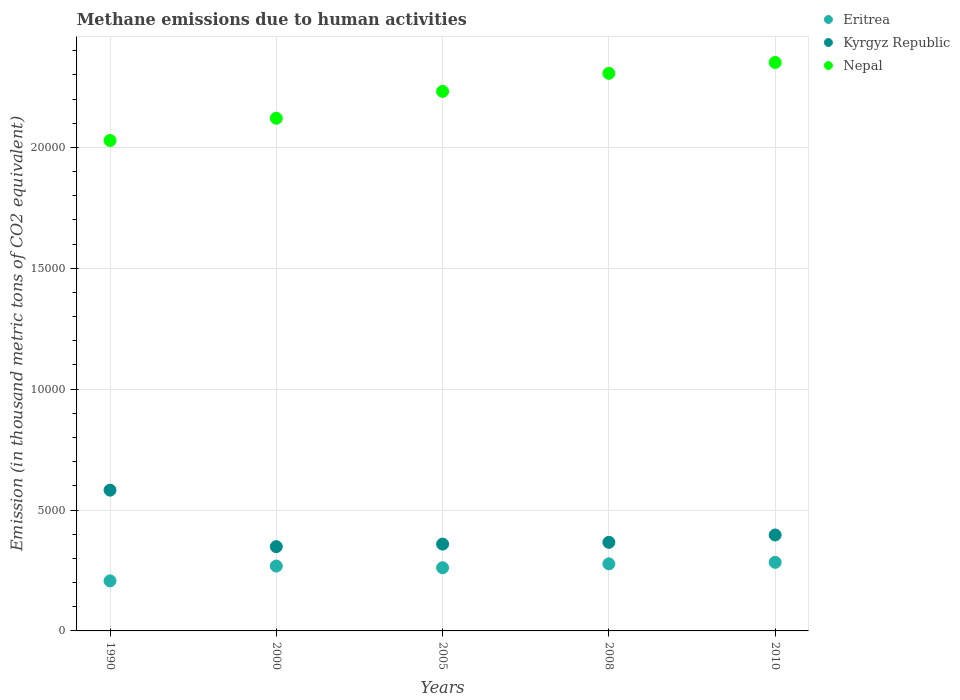How many different coloured dotlines are there?
Provide a short and direct response. 3. What is the amount of methane emitted in Nepal in 2005?
Give a very brief answer. 2.23e+04. Across all years, what is the maximum amount of methane emitted in Nepal?
Ensure brevity in your answer.  2.35e+04. Across all years, what is the minimum amount of methane emitted in Kyrgyz Republic?
Your response must be concise. 3485.8. In which year was the amount of methane emitted in Nepal maximum?
Keep it short and to the point. 2010. What is the total amount of methane emitted in Kyrgyz Republic in the graph?
Ensure brevity in your answer.  2.05e+04. What is the difference between the amount of methane emitted in Nepal in 2000 and that in 2010?
Offer a terse response. -2306. What is the difference between the amount of methane emitted in Nepal in 2010 and the amount of methane emitted in Eritrea in 2008?
Make the answer very short. 2.07e+04. What is the average amount of methane emitted in Eritrea per year?
Provide a succinct answer. 2595.64. In the year 2005, what is the difference between the amount of methane emitted in Eritrea and amount of methane emitted in Kyrgyz Republic?
Give a very brief answer. -977.7. What is the ratio of the amount of methane emitted in Nepal in 2000 to that in 2008?
Your answer should be compact. 0.92. What is the difference between the highest and the second highest amount of methane emitted in Kyrgyz Republic?
Provide a short and direct response. 1854.2. What is the difference between the highest and the lowest amount of methane emitted in Kyrgyz Republic?
Your answer should be compact. 2336.8. In how many years, is the amount of methane emitted in Kyrgyz Republic greater than the average amount of methane emitted in Kyrgyz Republic taken over all years?
Offer a very short reply. 1. Is the sum of the amount of methane emitted in Kyrgyz Republic in 2005 and 2010 greater than the maximum amount of methane emitted in Nepal across all years?
Your response must be concise. No. Is it the case that in every year, the sum of the amount of methane emitted in Nepal and amount of methane emitted in Eritrea  is greater than the amount of methane emitted in Kyrgyz Republic?
Make the answer very short. Yes. Is the amount of methane emitted in Eritrea strictly less than the amount of methane emitted in Nepal over the years?
Give a very brief answer. Yes. How many dotlines are there?
Offer a very short reply. 3. How many years are there in the graph?
Keep it short and to the point. 5. What is the difference between two consecutive major ticks on the Y-axis?
Make the answer very short. 5000. Does the graph contain any zero values?
Keep it short and to the point. No. Where does the legend appear in the graph?
Make the answer very short. Top right. How many legend labels are there?
Your answer should be very brief. 3. How are the legend labels stacked?
Offer a very short reply. Vertical. What is the title of the graph?
Provide a short and direct response. Methane emissions due to human activities. What is the label or title of the X-axis?
Your response must be concise. Years. What is the label or title of the Y-axis?
Offer a terse response. Emission (in thousand metric tons of CO2 equivalent). What is the Emission (in thousand metric tons of CO2 equivalent) in Eritrea in 1990?
Your answer should be very brief. 2070.6. What is the Emission (in thousand metric tons of CO2 equivalent) in Kyrgyz Republic in 1990?
Ensure brevity in your answer.  5822.6. What is the Emission (in thousand metric tons of CO2 equivalent) in Nepal in 1990?
Give a very brief answer. 2.03e+04. What is the Emission (in thousand metric tons of CO2 equivalent) in Eritrea in 2000?
Your answer should be compact. 2682.3. What is the Emission (in thousand metric tons of CO2 equivalent) of Kyrgyz Republic in 2000?
Provide a short and direct response. 3485.8. What is the Emission (in thousand metric tons of CO2 equivalent) of Nepal in 2000?
Give a very brief answer. 2.12e+04. What is the Emission (in thousand metric tons of CO2 equivalent) of Eritrea in 2005?
Make the answer very short. 2613.6. What is the Emission (in thousand metric tons of CO2 equivalent) in Kyrgyz Republic in 2005?
Offer a terse response. 3591.3. What is the Emission (in thousand metric tons of CO2 equivalent) of Nepal in 2005?
Ensure brevity in your answer.  2.23e+04. What is the Emission (in thousand metric tons of CO2 equivalent) in Eritrea in 2008?
Your response must be concise. 2774.7. What is the Emission (in thousand metric tons of CO2 equivalent) of Kyrgyz Republic in 2008?
Provide a succinct answer. 3664.5. What is the Emission (in thousand metric tons of CO2 equivalent) of Nepal in 2008?
Offer a very short reply. 2.31e+04. What is the Emission (in thousand metric tons of CO2 equivalent) in Eritrea in 2010?
Give a very brief answer. 2837. What is the Emission (in thousand metric tons of CO2 equivalent) of Kyrgyz Republic in 2010?
Your response must be concise. 3968.4. What is the Emission (in thousand metric tons of CO2 equivalent) of Nepal in 2010?
Your answer should be very brief. 2.35e+04. Across all years, what is the maximum Emission (in thousand metric tons of CO2 equivalent) in Eritrea?
Give a very brief answer. 2837. Across all years, what is the maximum Emission (in thousand metric tons of CO2 equivalent) of Kyrgyz Republic?
Offer a very short reply. 5822.6. Across all years, what is the maximum Emission (in thousand metric tons of CO2 equivalent) in Nepal?
Provide a succinct answer. 2.35e+04. Across all years, what is the minimum Emission (in thousand metric tons of CO2 equivalent) of Eritrea?
Keep it short and to the point. 2070.6. Across all years, what is the minimum Emission (in thousand metric tons of CO2 equivalent) in Kyrgyz Republic?
Ensure brevity in your answer.  3485.8. Across all years, what is the minimum Emission (in thousand metric tons of CO2 equivalent) of Nepal?
Make the answer very short. 2.03e+04. What is the total Emission (in thousand metric tons of CO2 equivalent) in Eritrea in the graph?
Your answer should be very brief. 1.30e+04. What is the total Emission (in thousand metric tons of CO2 equivalent) in Kyrgyz Republic in the graph?
Your response must be concise. 2.05e+04. What is the total Emission (in thousand metric tons of CO2 equivalent) of Nepal in the graph?
Offer a very short reply. 1.10e+05. What is the difference between the Emission (in thousand metric tons of CO2 equivalent) of Eritrea in 1990 and that in 2000?
Your response must be concise. -611.7. What is the difference between the Emission (in thousand metric tons of CO2 equivalent) of Kyrgyz Republic in 1990 and that in 2000?
Your response must be concise. 2336.8. What is the difference between the Emission (in thousand metric tons of CO2 equivalent) in Nepal in 1990 and that in 2000?
Provide a short and direct response. -920.3. What is the difference between the Emission (in thousand metric tons of CO2 equivalent) in Eritrea in 1990 and that in 2005?
Give a very brief answer. -543. What is the difference between the Emission (in thousand metric tons of CO2 equivalent) of Kyrgyz Republic in 1990 and that in 2005?
Give a very brief answer. 2231.3. What is the difference between the Emission (in thousand metric tons of CO2 equivalent) in Nepal in 1990 and that in 2005?
Offer a terse response. -2031.1. What is the difference between the Emission (in thousand metric tons of CO2 equivalent) in Eritrea in 1990 and that in 2008?
Give a very brief answer. -704.1. What is the difference between the Emission (in thousand metric tons of CO2 equivalent) in Kyrgyz Republic in 1990 and that in 2008?
Provide a short and direct response. 2158.1. What is the difference between the Emission (in thousand metric tons of CO2 equivalent) of Nepal in 1990 and that in 2008?
Make the answer very short. -2778.1. What is the difference between the Emission (in thousand metric tons of CO2 equivalent) of Eritrea in 1990 and that in 2010?
Provide a succinct answer. -766.4. What is the difference between the Emission (in thousand metric tons of CO2 equivalent) of Kyrgyz Republic in 1990 and that in 2010?
Offer a terse response. 1854.2. What is the difference between the Emission (in thousand metric tons of CO2 equivalent) in Nepal in 1990 and that in 2010?
Provide a short and direct response. -3226.3. What is the difference between the Emission (in thousand metric tons of CO2 equivalent) of Eritrea in 2000 and that in 2005?
Make the answer very short. 68.7. What is the difference between the Emission (in thousand metric tons of CO2 equivalent) in Kyrgyz Republic in 2000 and that in 2005?
Offer a very short reply. -105.5. What is the difference between the Emission (in thousand metric tons of CO2 equivalent) of Nepal in 2000 and that in 2005?
Ensure brevity in your answer.  -1110.8. What is the difference between the Emission (in thousand metric tons of CO2 equivalent) of Eritrea in 2000 and that in 2008?
Your answer should be very brief. -92.4. What is the difference between the Emission (in thousand metric tons of CO2 equivalent) in Kyrgyz Republic in 2000 and that in 2008?
Offer a very short reply. -178.7. What is the difference between the Emission (in thousand metric tons of CO2 equivalent) of Nepal in 2000 and that in 2008?
Your answer should be compact. -1857.8. What is the difference between the Emission (in thousand metric tons of CO2 equivalent) in Eritrea in 2000 and that in 2010?
Offer a terse response. -154.7. What is the difference between the Emission (in thousand metric tons of CO2 equivalent) in Kyrgyz Republic in 2000 and that in 2010?
Your response must be concise. -482.6. What is the difference between the Emission (in thousand metric tons of CO2 equivalent) in Nepal in 2000 and that in 2010?
Your answer should be compact. -2306. What is the difference between the Emission (in thousand metric tons of CO2 equivalent) of Eritrea in 2005 and that in 2008?
Provide a succinct answer. -161.1. What is the difference between the Emission (in thousand metric tons of CO2 equivalent) in Kyrgyz Republic in 2005 and that in 2008?
Give a very brief answer. -73.2. What is the difference between the Emission (in thousand metric tons of CO2 equivalent) of Nepal in 2005 and that in 2008?
Your answer should be compact. -747. What is the difference between the Emission (in thousand metric tons of CO2 equivalent) in Eritrea in 2005 and that in 2010?
Your answer should be very brief. -223.4. What is the difference between the Emission (in thousand metric tons of CO2 equivalent) of Kyrgyz Republic in 2005 and that in 2010?
Offer a very short reply. -377.1. What is the difference between the Emission (in thousand metric tons of CO2 equivalent) of Nepal in 2005 and that in 2010?
Keep it short and to the point. -1195.2. What is the difference between the Emission (in thousand metric tons of CO2 equivalent) in Eritrea in 2008 and that in 2010?
Ensure brevity in your answer.  -62.3. What is the difference between the Emission (in thousand metric tons of CO2 equivalent) of Kyrgyz Republic in 2008 and that in 2010?
Provide a succinct answer. -303.9. What is the difference between the Emission (in thousand metric tons of CO2 equivalent) of Nepal in 2008 and that in 2010?
Give a very brief answer. -448.2. What is the difference between the Emission (in thousand metric tons of CO2 equivalent) of Eritrea in 1990 and the Emission (in thousand metric tons of CO2 equivalent) of Kyrgyz Republic in 2000?
Keep it short and to the point. -1415.2. What is the difference between the Emission (in thousand metric tons of CO2 equivalent) in Eritrea in 1990 and the Emission (in thousand metric tons of CO2 equivalent) in Nepal in 2000?
Ensure brevity in your answer.  -1.91e+04. What is the difference between the Emission (in thousand metric tons of CO2 equivalent) in Kyrgyz Republic in 1990 and the Emission (in thousand metric tons of CO2 equivalent) in Nepal in 2000?
Offer a very short reply. -1.54e+04. What is the difference between the Emission (in thousand metric tons of CO2 equivalent) of Eritrea in 1990 and the Emission (in thousand metric tons of CO2 equivalent) of Kyrgyz Republic in 2005?
Offer a very short reply. -1520.7. What is the difference between the Emission (in thousand metric tons of CO2 equivalent) of Eritrea in 1990 and the Emission (in thousand metric tons of CO2 equivalent) of Nepal in 2005?
Your answer should be very brief. -2.02e+04. What is the difference between the Emission (in thousand metric tons of CO2 equivalent) of Kyrgyz Republic in 1990 and the Emission (in thousand metric tons of CO2 equivalent) of Nepal in 2005?
Make the answer very short. -1.65e+04. What is the difference between the Emission (in thousand metric tons of CO2 equivalent) of Eritrea in 1990 and the Emission (in thousand metric tons of CO2 equivalent) of Kyrgyz Republic in 2008?
Offer a terse response. -1593.9. What is the difference between the Emission (in thousand metric tons of CO2 equivalent) of Eritrea in 1990 and the Emission (in thousand metric tons of CO2 equivalent) of Nepal in 2008?
Keep it short and to the point. -2.10e+04. What is the difference between the Emission (in thousand metric tons of CO2 equivalent) of Kyrgyz Republic in 1990 and the Emission (in thousand metric tons of CO2 equivalent) of Nepal in 2008?
Your answer should be very brief. -1.72e+04. What is the difference between the Emission (in thousand metric tons of CO2 equivalent) in Eritrea in 1990 and the Emission (in thousand metric tons of CO2 equivalent) in Kyrgyz Republic in 2010?
Provide a succinct answer. -1897.8. What is the difference between the Emission (in thousand metric tons of CO2 equivalent) of Eritrea in 1990 and the Emission (in thousand metric tons of CO2 equivalent) of Nepal in 2010?
Your response must be concise. -2.14e+04. What is the difference between the Emission (in thousand metric tons of CO2 equivalent) of Kyrgyz Republic in 1990 and the Emission (in thousand metric tons of CO2 equivalent) of Nepal in 2010?
Ensure brevity in your answer.  -1.77e+04. What is the difference between the Emission (in thousand metric tons of CO2 equivalent) in Eritrea in 2000 and the Emission (in thousand metric tons of CO2 equivalent) in Kyrgyz Republic in 2005?
Your answer should be compact. -909. What is the difference between the Emission (in thousand metric tons of CO2 equivalent) in Eritrea in 2000 and the Emission (in thousand metric tons of CO2 equivalent) in Nepal in 2005?
Your answer should be very brief. -1.96e+04. What is the difference between the Emission (in thousand metric tons of CO2 equivalent) in Kyrgyz Republic in 2000 and the Emission (in thousand metric tons of CO2 equivalent) in Nepal in 2005?
Offer a terse response. -1.88e+04. What is the difference between the Emission (in thousand metric tons of CO2 equivalent) of Eritrea in 2000 and the Emission (in thousand metric tons of CO2 equivalent) of Kyrgyz Republic in 2008?
Provide a succinct answer. -982.2. What is the difference between the Emission (in thousand metric tons of CO2 equivalent) of Eritrea in 2000 and the Emission (in thousand metric tons of CO2 equivalent) of Nepal in 2008?
Your answer should be compact. -2.04e+04. What is the difference between the Emission (in thousand metric tons of CO2 equivalent) in Kyrgyz Republic in 2000 and the Emission (in thousand metric tons of CO2 equivalent) in Nepal in 2008?
Offer a very short reply. -1.96e+04. What is the difference between the Emission (in thousand metric tons of CO2 equivalent) of Eritrea in 2000 and the Emission (in thousand metric tons of CO2 equivalent) of Kyrgyz Republic in 2010?
Ensure brevity in your answer.  -1286.1. What is the difference between the Emission (in thousand metric tons of CO2 equivalent) in Eritrea in 2000 and the Emission (in thousand metric tons of CO2 equivalent) in Nepal in 2010?
Offer a very short reply. -2.08e+04. What is the difference between the Emission (in thousand metric tons of CO2 equivalent) of Kyrgyz Republic in 2000 and the Emission (in thousand metric tons of CO2 equivalent) of Nepal in 2010?
Give a very brief answer. -2.00e+04. What is the difference between the Emission (in thousand metric tons of CO2 equivalent) of Eritrea in 2005 and the Emission (in thousand metric tons of CO2 equivalent) of Kyrgyz Republic in 2008?
Ensure brevity in your answer.  -1050.9. What is the difference between the Emission (in thousand metric tons of CO2 equivalent) of Eritrea in 2005 and the Emission (in thousand metric tons of CO2 equivalent) of Nepal in 2008?
Your response must be concise. -2.05e+04. What is the difference between the Emission (in thousand metric tons of CO2 equivalent) in Kyrgyz Republic in 2005 and the Emission (in thousand metric tons of CO2 equivalent) in Nepal in 2008?
Make the answer very short. -1.95e+04. What is the difference between the Emission (in thousand metric tons of CO2 equivalent) in Eritrea in 2005 and the Emission (in thousand metric tons of CO2 equivalent) in Kyrgyz Republic in 2010?
Keep it short and to the point. -1354.8. What is the difference between the Emission (in thousand metric tons of CO2 equivalent) of Eritrea in 2005 and the Emission (in thousand metric tons of CO2 equivalent) of Nepal in 2010?
Give a very brief answer. -2.09e+04. What is the difference between the Emission (in thousand metric tons of CO2 equivalent) in Kyrgyz Republic in 2005 and the Emission (in thousand metric tons of CO2 equivalent) in Nepal in 2010?
Keep it short and to the point. -1.99e+04. What is the difference between the Emission (in thousand metric tons of CO2 equivalent) in Eritrea in 2008 and the Emission (in thousand metric tons of CO2 equivalent) in Kyrgyz Republic in 2010?
Your answer should be compact. -1193.7. What is the difference between the Emission (in thousand metric tons of CO2 equivalent) in Eritrea in 2008 and the Emission (in thousand metric tons of CO2 equivalent) in Nepal in 2010?
Keep it short and to the point. -2.07e+04. What is the difference between the Emission (in thousand metric tons of CO2 equivalent) in Kyrgyz Republic in 2008 and the Emission (in thousand metric tons of CO2 equivalent) in Nepal in 2010?
Your answer should be very brief. -1.98e+04. What is the average Emission (in thousand metric tons of CO2 equivalent) of Eritrea per year?
Offer a very short reply. 2595.64. What is the average Emission (in thousand metric tons of CO2 equivalent) in Kyrgyz Republic per year?
Offer a very short reply. 4106.52. What is the average Emission (in thousand metric tons of CO2 equivalent) in Nepal per year?
Keep it short and to the point. 2.21e+04. In the year 1990, what is the difference between the Emission (in thousand metric tons of CO2 equivalent) of Eritrea and Emission (in thousand metric tons of CO2 equivalent) of Kyrgyz Republic?
Your answer should be compact. -3752. In the year 1990, what is the difference between the Emission (in thousand metric tons of CO2 equivalent) of Eritrea and Emission (in thousand metric tons of CO2 equivalent) of Nepal?
Provide a succinct answer. -1.82e+04. In the year 1990, what is the difference between the Emission (in thousand metric tons of CO2 equivalent) in Kyrgyz Republic and Emission (in thousand metric tons of CO2 equivalent) in Nepal?
Your answer should be compact. -1.45e+04. In the year 2000, what is the difference between the Emission (in thousand metric tons of CO2 equivalent) in Eritrea and Emission (in thousand metric tons of CO2 equivalent) in Kyrgyz Republic?
Provide a short and direct response. -803.5. In the year 2000, what is the difference between the Emission (in thousand metric tons of CO2 equivalent) of Eritrea and Emission (in thousand metric tons of CO2 equivalent) of Nepal?
Ensure brevity in your answer.  -1.85e+04. In the year 2000, what is the difference between the Emission (in thousand metric tons of CO2 equivalent) of Kyrgyz Republic and Emission (in thousand metric tons of CO2 equivalent) of Nepal?
Your response must be concise. -1.77e+04. In the year 2005, what is the difference between the Emission (in thousand metric tons of CO2 equivalent) in Eritrea and Emission (in thousand metric tons of CO2 equivalent) in Kyrgyz Republic?
Provide a short and direct response. -977.7. In the year 2005, what is the difference between the Emission (in thousand metric tons of CO2 equivalent) of Eritrea and Emission (in thousand metric tons of CO2 equivalent) of Nepal?
Your answer should be very brief. -1.97e+04. In the year 2005, what is the difference between the Emission (in thousand metric tons of CO2 equivalent) of Kyrgyz Republic and Emission (in thousand metric tons of CO2 equivalent) of Nepal?
Your response must be concise. -1.87e+04. In the year 2008, what is the difference between the Emission (in thousand metric tons of CO2 equivalent) of Eritrea and Emission (in thousand metric tons of CO2 equivalent) of Kyrgyz Republic?
Your answer should be compact. -889.8. In the year 2008, what is the difference between the Emission (in thousand metric tons of CO2 equivalent) of Eritrea and Emission (in thousand metric tons of CO2 equivalent) of Nepal?
Offer a terse response. -2.03e+04. In the year 2008, what is the difference between the Emission (in thousand metric tons of CO2 equivalent) of Kyrgyz Republic and Emission (in thousand metric tons of CO2 equivalent) of Nepal?
Offer a very short reply. -1.94e+04. In the year 2010, what is the difference between the Emission (in thousand metric tons of CO2 equivalent) in Eritrea and Emission (in thousand metric tons of CO2 equivalent) in Kyrgyz Republic?
Offer a terse response. -1131.4. In the year 2010, what is the difference between the Emission (in thousand metric tons of CO2 equivalent) of Eritrea and Emission (in thousand metric tons of CO2 equivalent) of Nepal?
Offer a very short reply. -2.07e+04. In the year 2010, what is the difference between the Emission (in thousand metric tons of CO2 equivalent) in Kyrgyz Republic and Emission (in thousand metric tons of CO2 equivalent) in Nepal?
Give a very brief answer. -1.95e+04. What is the ratio of the Emission (in thousand metric tons of CO2 equivalent) in Eritrea in 1990 to that in 2000?
Your answer should be very brief. 0.77. What is the ratio of the Emission (in thousand metric tons of CO2 equivalent) of Kyrgyz Republic in 1990 to that in 2000?
Keep it short and to the point. 1.67. What is the ratio of the Emission (in thousand metric tons of CO2 equivalent) in Nepal in 1990 to that in 2000?
Keep it short and to the point. 0.96. What is the ratio of the Emission (in thousand metric tons of CO2 equivalent) of Eritrea in 1990 to that in 2005?
Ensure brevity in your answer.  0.79. What is the ratio of the Emission (in thousand metric tons of CO2 equivalent) in Kyrgyz Republic in 1990 to that in 2005?
Provide a short and direct response. 1.62. What is the ratio of the Emission (in thousand metric tons of CO2 equivalent) of Nepal in 1990 to that in 2005?
Provide a succinct answer. 0.91. What is the ratio of the Emission (in thousand metric tons of CO2 equivalent) in Eritrea in 1990 to that in 2008?
Your response must be concise. 0.75. What is the ratio of the Emission (in thousand metric tons of CO2 equivalent) in Kyrgyz Republic in 1990 to that in 2008?
Offer a terse response. 1.59. What is the ratio of the Emission (in thousand metric tons of CO2 equivalent) of Nepal in 1990 to that in 2008?
Offer a terse response. 0.88. What is the ratio of the Emission (in thousand metric tons of CO2 equivalent) of Eritrea in 1990 to that in 2010?
Offer a very short reply. 0.73. What is the ratio of the Emission (in thousand metric tons of CO2 equivalent) of Kyrgyz Republic in 1990 to that in 2010?
Provide a short and direct response. 1.47. What is the ratio of the Emission (in thousand metric tons of CO2 equivalent) in Nepal in 1990 to that in 2010?
Keep it short and to the point. 0.86. What is the ratio of the Emission (in thousand metric tons of CO2 equivalent) in Eritrea in 2000 to that in 2005?
Your answer should be compact. 1.03. What is the ratio of the Emission (in thousand metric tons of CO2 equivalent) of Kyrgyz Republic in 2000 to that in 2005?
Your response must be concise. 0.97. What is the ratio of the Emission (in thousand metric tons of CO2 equivalent) of Nepal in 2000 to that in 2005?
Provide a short and direct response. 0.95. What is the ratio of the Emission (in thousand metric tons of CO2 equivalent) in Eritrea in 2000 to that in 2008?
Provide a short and direct response. 0.97. What is the ratio of the Emission (in thousand metric tons of CO2 equivalent) in Kyrgyz Republic in 2000 to that in 2008?
Your answer should be very brief. 0.95. What is the ratio of the Emission (in thousand metric tons of CO2 equivalent) in Nepal in 2000 to that in 2008?
Keep it short and to the point. 0.92. What is the ratio of the Emission (in thousand metric tons of CO2 equivalent) in Eritrea in 2000 to that in 2010?
Your answer should be very brief. 0.95. What is the ratio of the Emission (in thousand metric tons of CO2 equivalent) in Kyrgyz Republic in 2000 to that in 2010?
Provide a short and direct response. 0.88. What is the ratio of the Emission (in thousand metric tons of CO2 equivalent) in Nepal in 2000 to that in 2010?
Your response must be concise. 0.9. What is the ratio of the Emission (in thousand metric tons of CO2 equivalent) in Eritrea in 2005 to that in 2008?
Make the answer very short. 0.94. What is the ratio of the Emission (in thousand metric tons of CO2 equivalent) in Kyrgyz Republic in 2005 to that in 2008?
Provide a short and direct response. 0.98. What is the ratio of the Emission (in thousand metric tons of CO2 equivalent) in Nepal in 2005 to that in 2008?
Provide a succinct answer. 0.97. What is the ratio of the Emission (in thousand metric tons of CO2 equivalent) of Eritrea in 2005 to that in 2010?
Make the answer very short. 0.92. What is the ratio of the Emission (in thousand metric tons of CO2 equivalent) of Kyrgyz Republic in 2005 to that in 2010?
Offer a very short reply. 0.91. What is the ratio of the Emission (in thousand metric tons of CO2 equivalent) in Nepal in 2005 to that in 2010?
Offer a very short reply. 0.95. What is the ratio of the Emission (in thousand metric tons of CO2 equivalent) in Kyrgyz Republic in 2008 to that in 2010?
Your answer should be very brief. 0.92. What is the ratio of the Emission (in thousand metric tons of CO2 equivalent) in Nepal in 2008 to that in 2010?
Provide a succinct answer. 0.98. What is the difference between the highest and the second highest Emission (in thousand metric tons of CO2 equivalent) of Eritrea?
Give a very brief answer. 62.3. What is the difference between the highest and the second highest Emission (in thousand metric tons of CO2 equivalent) of Kyrgyz Republic?
Give a very brief answer. 1854.2. What is the difference between the highest and the second highest Emission (in thousand metric tons of CO2 equivalent) of Nepal?
Offer a very short reply. 448.2. What is the difference between the highest and the lowest Emission (in thousand metric tons of CO2 equivalent) in Eritrea?
Your answer should be very brief. 766.4. What is the difference between the highest and the lowest Emission (in thousand metric tons of CO2 equivalent) of Kyrgyz Republic?
Your response must be concise. 2336.8. What is the difference between the highest and the lowest Emission (in thousand metric tons of CO2 equivalent) of Nepal?
Offer a very short reply. 3226.3. 